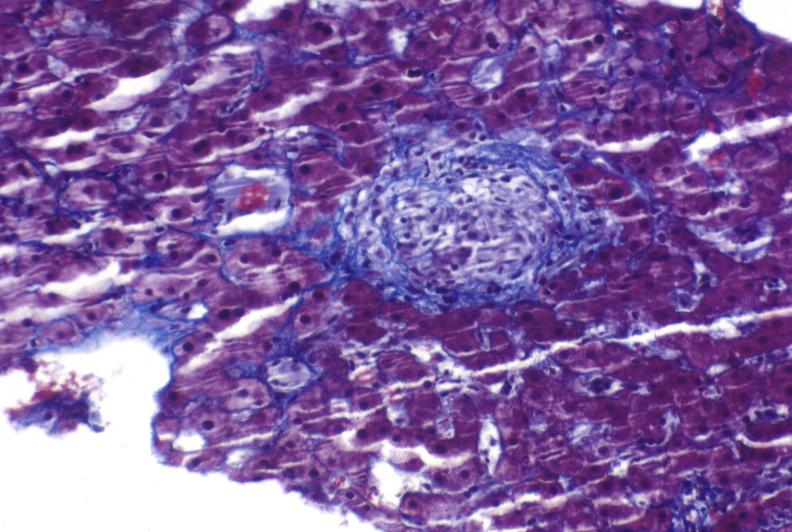s autopsy present?
Answer the question using a single word or phrase. No 